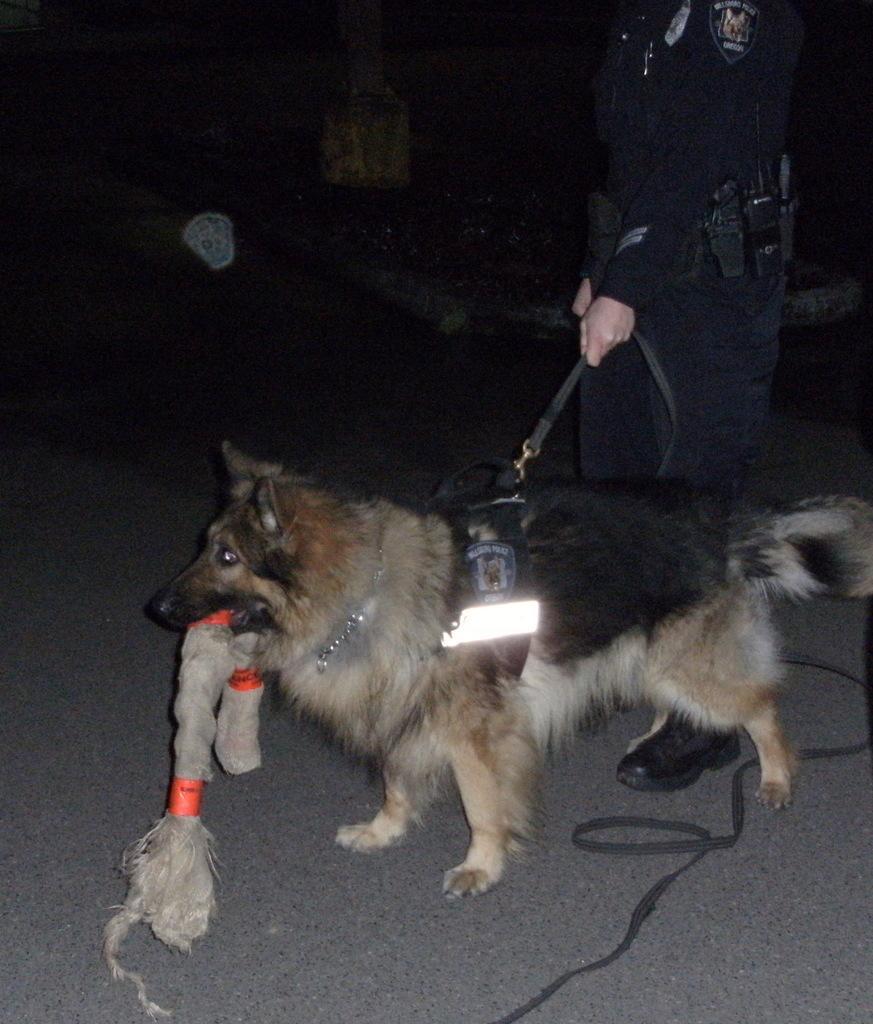In one or two sentences, can you explain what this image depicts? In this image we can see a dog on the road, here is the light, here a person is holding it. 